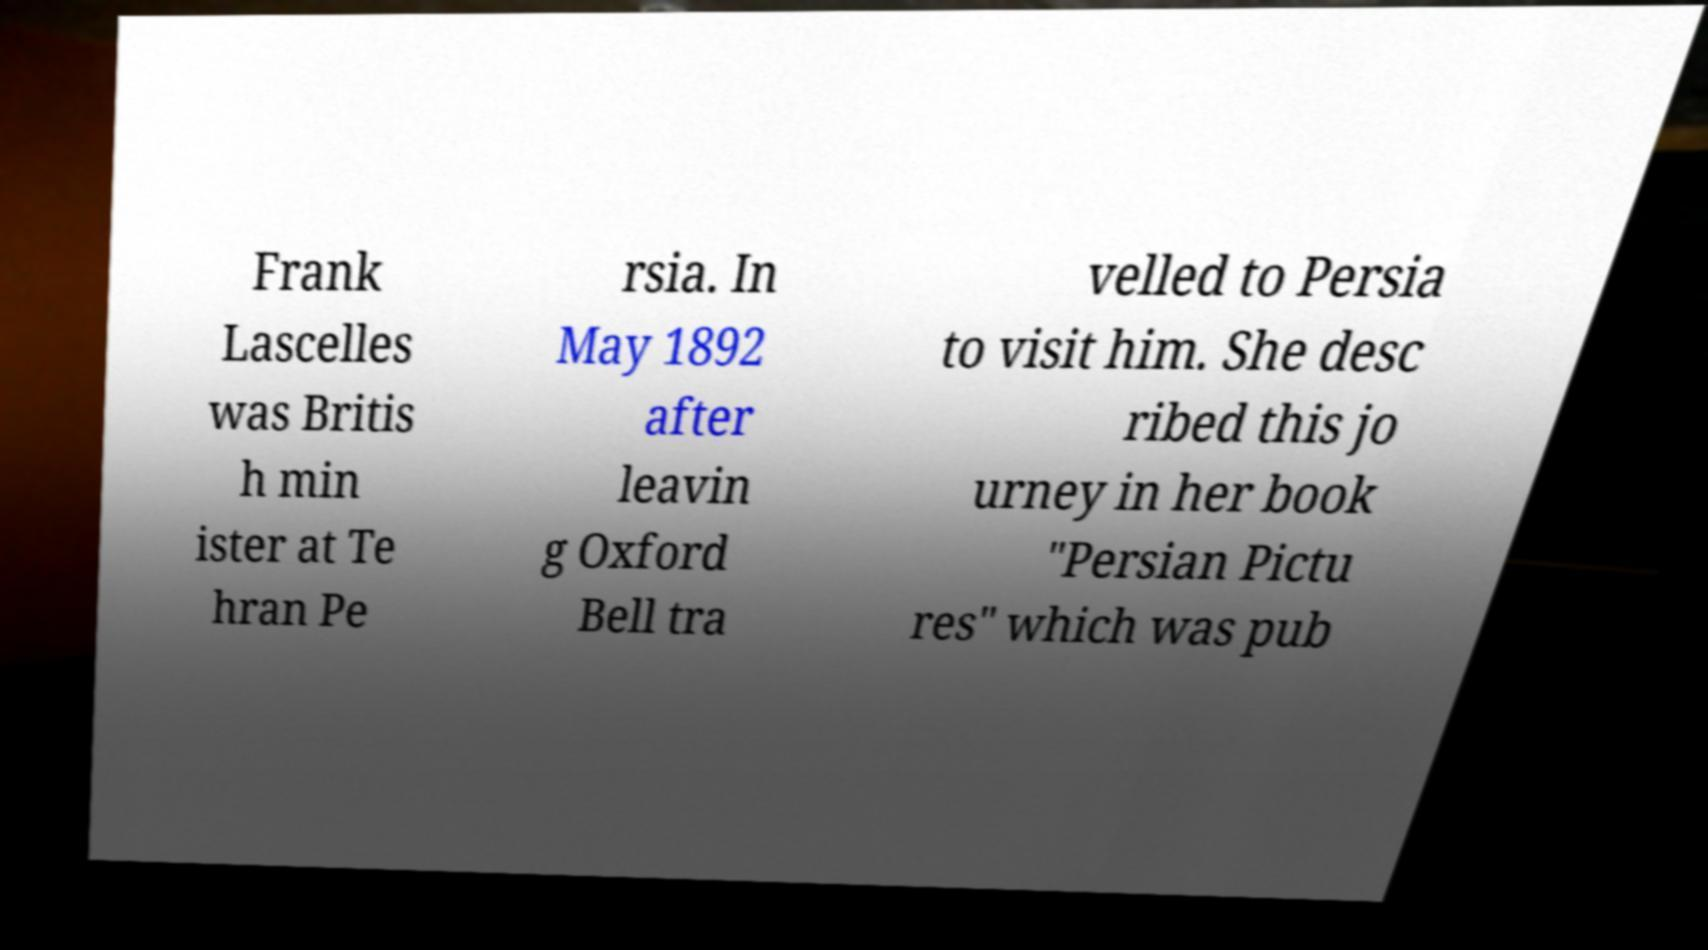Can you accurately transcribe the text from the provided image for me? Frank Lascelles was Britis h min ister at Te hran Pe rsia. In May 1892 after leavin g Oxford Bell tra velled to Persia to visit him. She desc ribed this jo urney in her book "Persian Pictu res" which was pub 